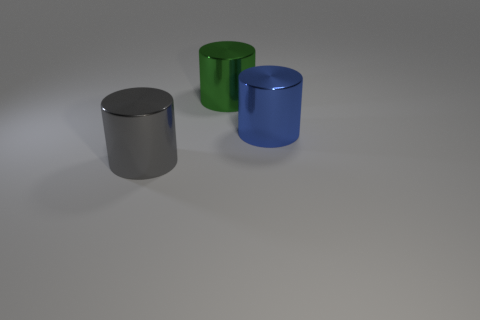Subtract all big green cylinders. How many cylinders are left? 2 Subtract all blue cylinders. How many cylinders are left? 2 Subtract 3 cylinders. How many cylinders are left? 0 Add 2 large green matte things. How many objects exist? 5 Subtract all purple spheres. How many red cylinders are left? 0 Subtract 0 gray spheres. How many objects are left? 3 Subtract all yellow cylinders. Subtract all cyan blocks. How many cylinders are left? 3 Subtract all yellow cubes. Subtract all big blue objects. How many objects are left? 2 Add 3 green metallic cylinders. How many green metallic cylinders are left? 4 Add 1 gray objects. How many gray objects exist? 2 